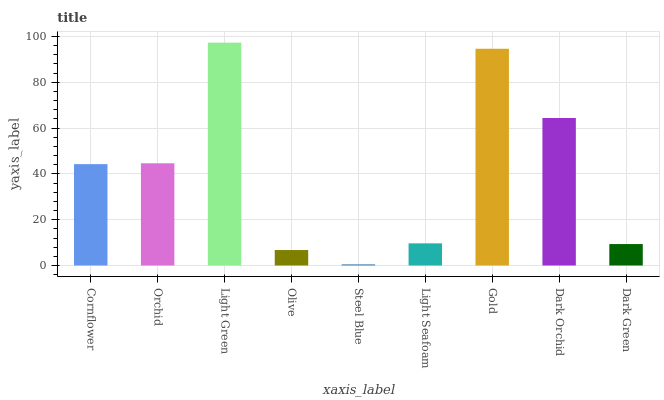Is Steel Blue the minimum?
Answer yes or no. Yes. Is Light Green the maximum?
Answer yes or no. Yes. Is Orchid the minimum?
Answer yes or no. No. Is Orchid the maximum?
Answer yes or no. No. Is Orchid greater than Cornflower?
Answer yes or no. Yes. Is Cornflower less than Orchid?
Answer yes or no. Yes. Is Cornflower greater than Orchid?
Answer yes or no. No. Is Orchid less than Cornflower?
Answer yes or no. No. Is Cornflower the high median?
Answer yes or no. Yes. Is Cornflower the low median?
Answer yes or no. Yes. Is Light Seafoam the high median?
Answer yes or no. No. Is Orchid the low median?
Answer yes or no. No. 